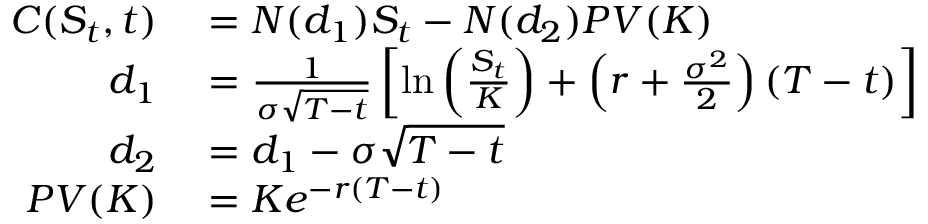<formula> <loc_0><loc_0><loc_500><loc_500>\begin{array} { r l } { C ( S _ { t } , t ) } & = N ( d _ { 1 } ) S _ { t } - N ( d _ { 2 } ) P V ( K ) } \\ { d _ { 1 } } & = { \frac { 1 } { \sigma { \sqrt { T - t } } } } \left [ \ln \left ( { \frac { S _ { t } } { K } } \right ) + \left ( r + { \frac { \sigma ^ { 2 } } { 2 } } \right ) ( T - t ) \right ] } \\ { d _ { 2 } } & = d _ { 1 } - \sigma { \sqrt { T - t } } } \\ { P V ( K ) } & = K e ^ { - r ( T - t ) } } \end{array}</formula> 